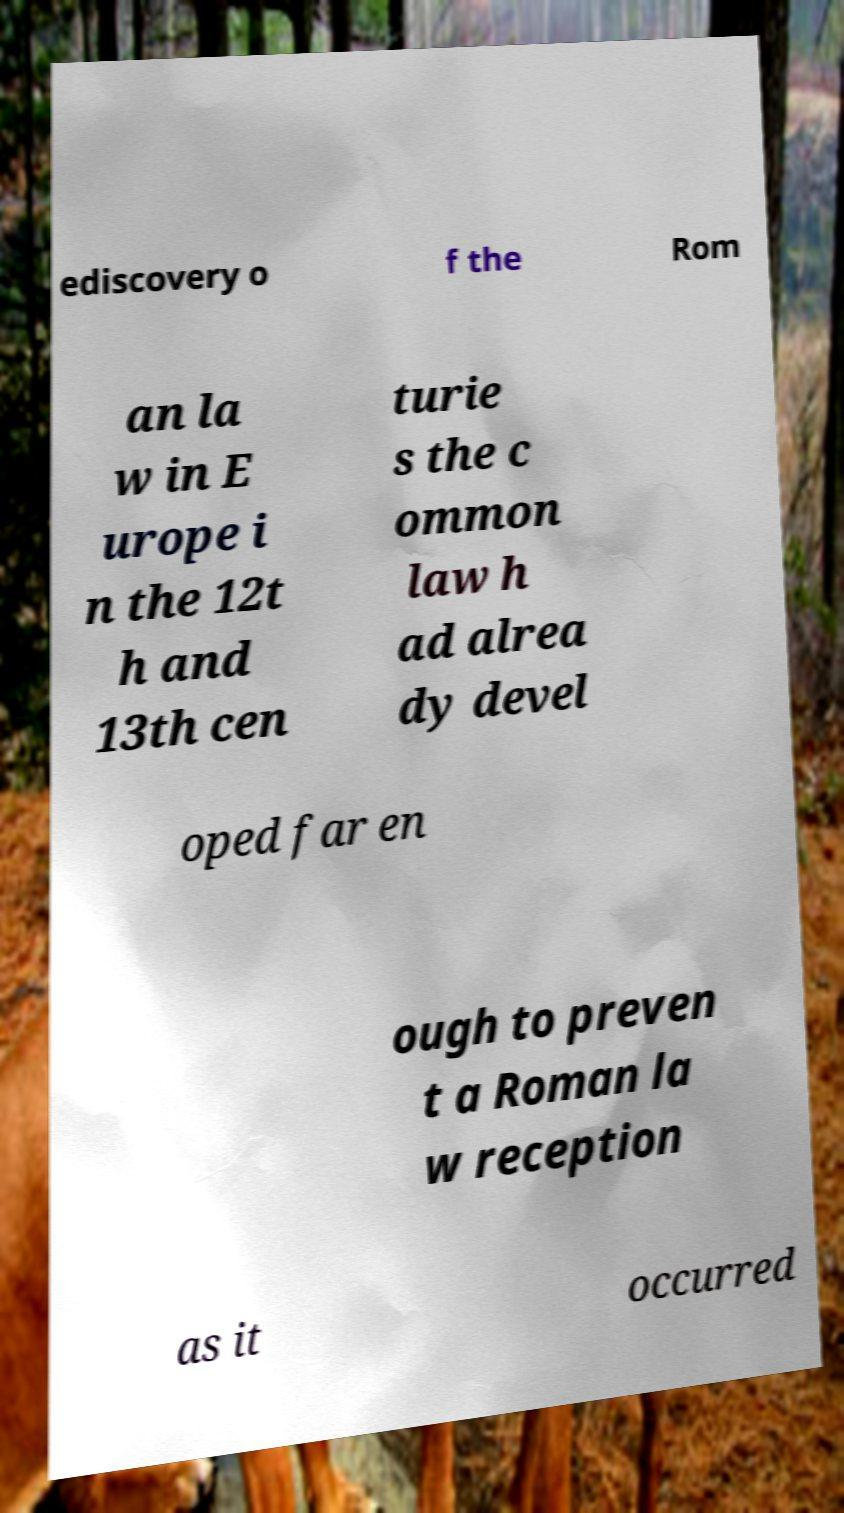For documentation purposes, I need the text within this image transcribed. Could you provide that? ediscovery o f the Rom an la w in E urope i n the 12t h and 13th cen turie s the c ommon law h ad alrea dy devel oped far en ough to preven t a Roman la w reception as it occurred 